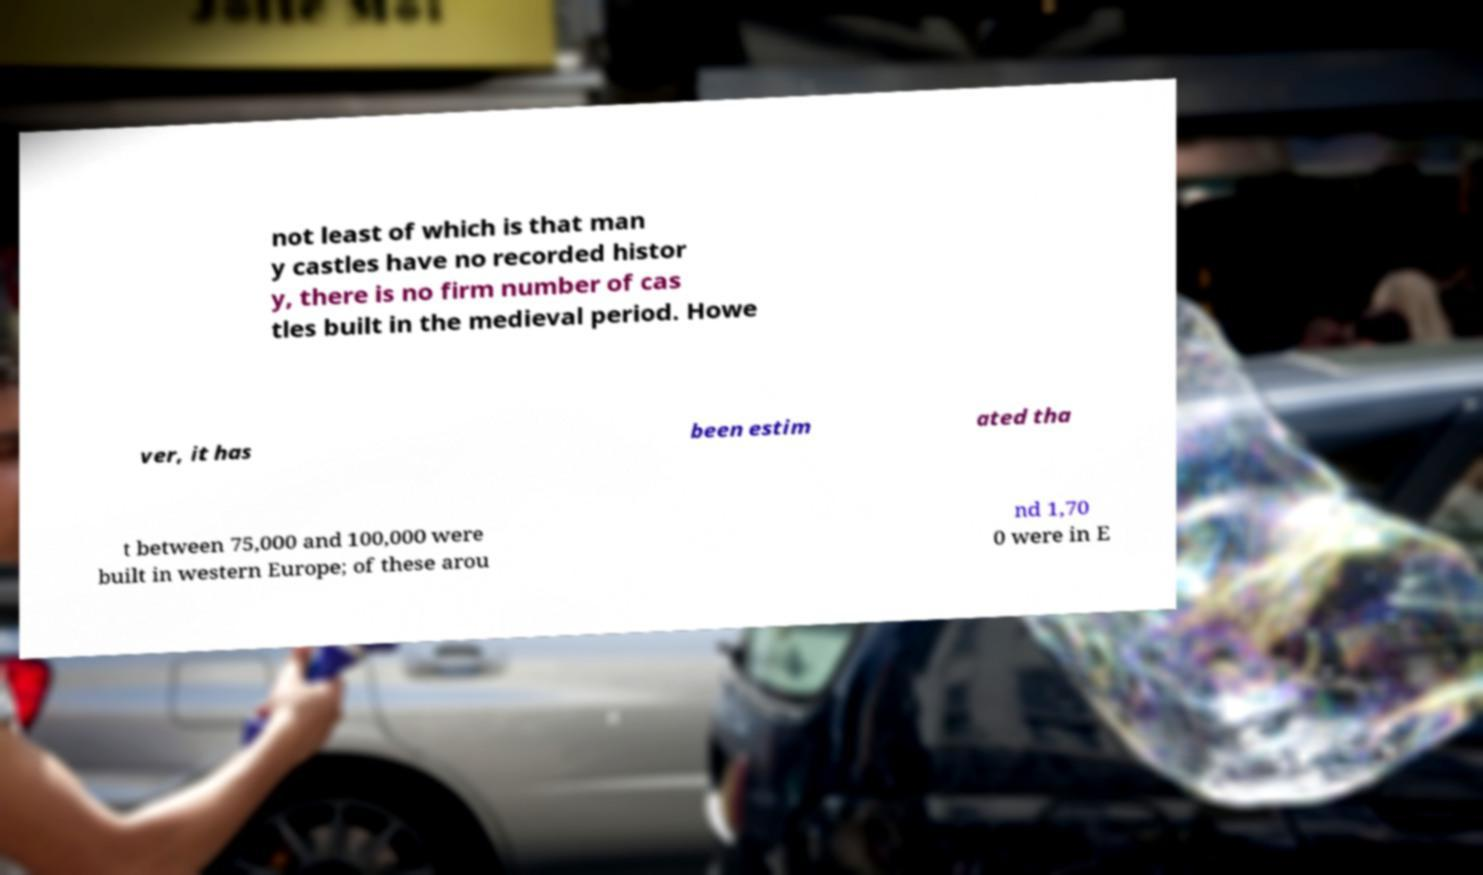Could you assist in decoding the text presented in this image and type it out clearly? not least of which is that man y castles have no recorded histor y, there is no firm number of cas tles built in the medieval period. Howe ver, it has been estim ated tha t between 75,000 and 100,000 were built in western Europe; of these arou nd 1,70 0 were in E 